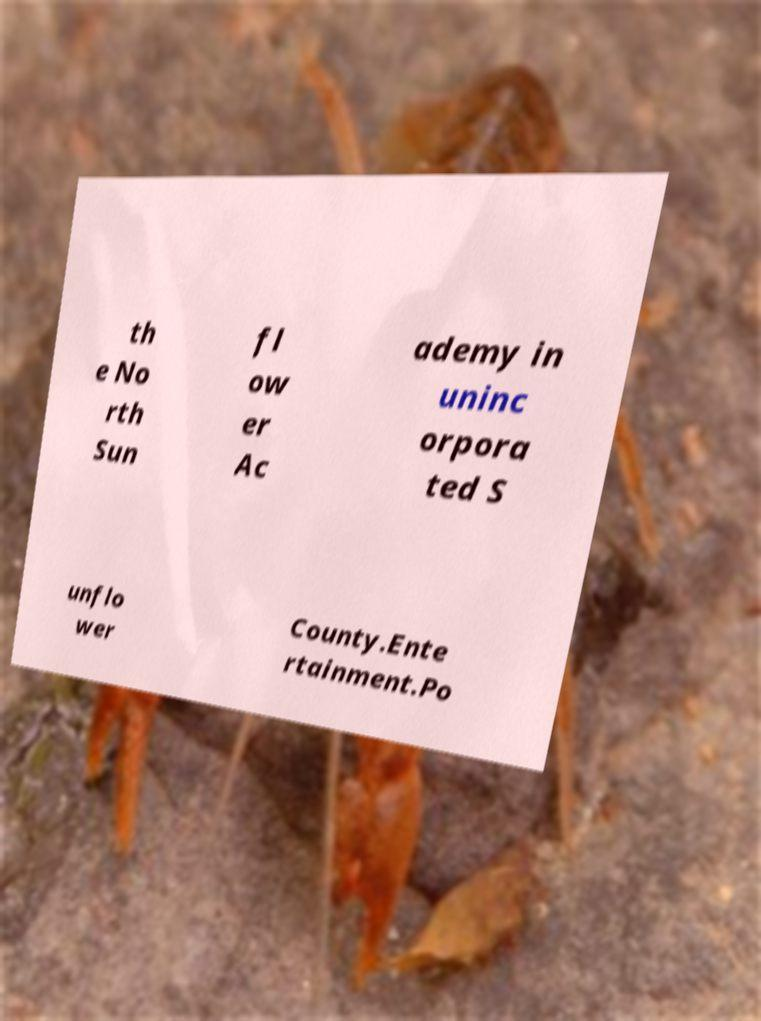Could you assist in decoding the text presented in this image and type it out clearly? th e No rth Sun fl ow er Ac ademy in uninc orpora ted S unflo wer County.Ente rtainment.Po 